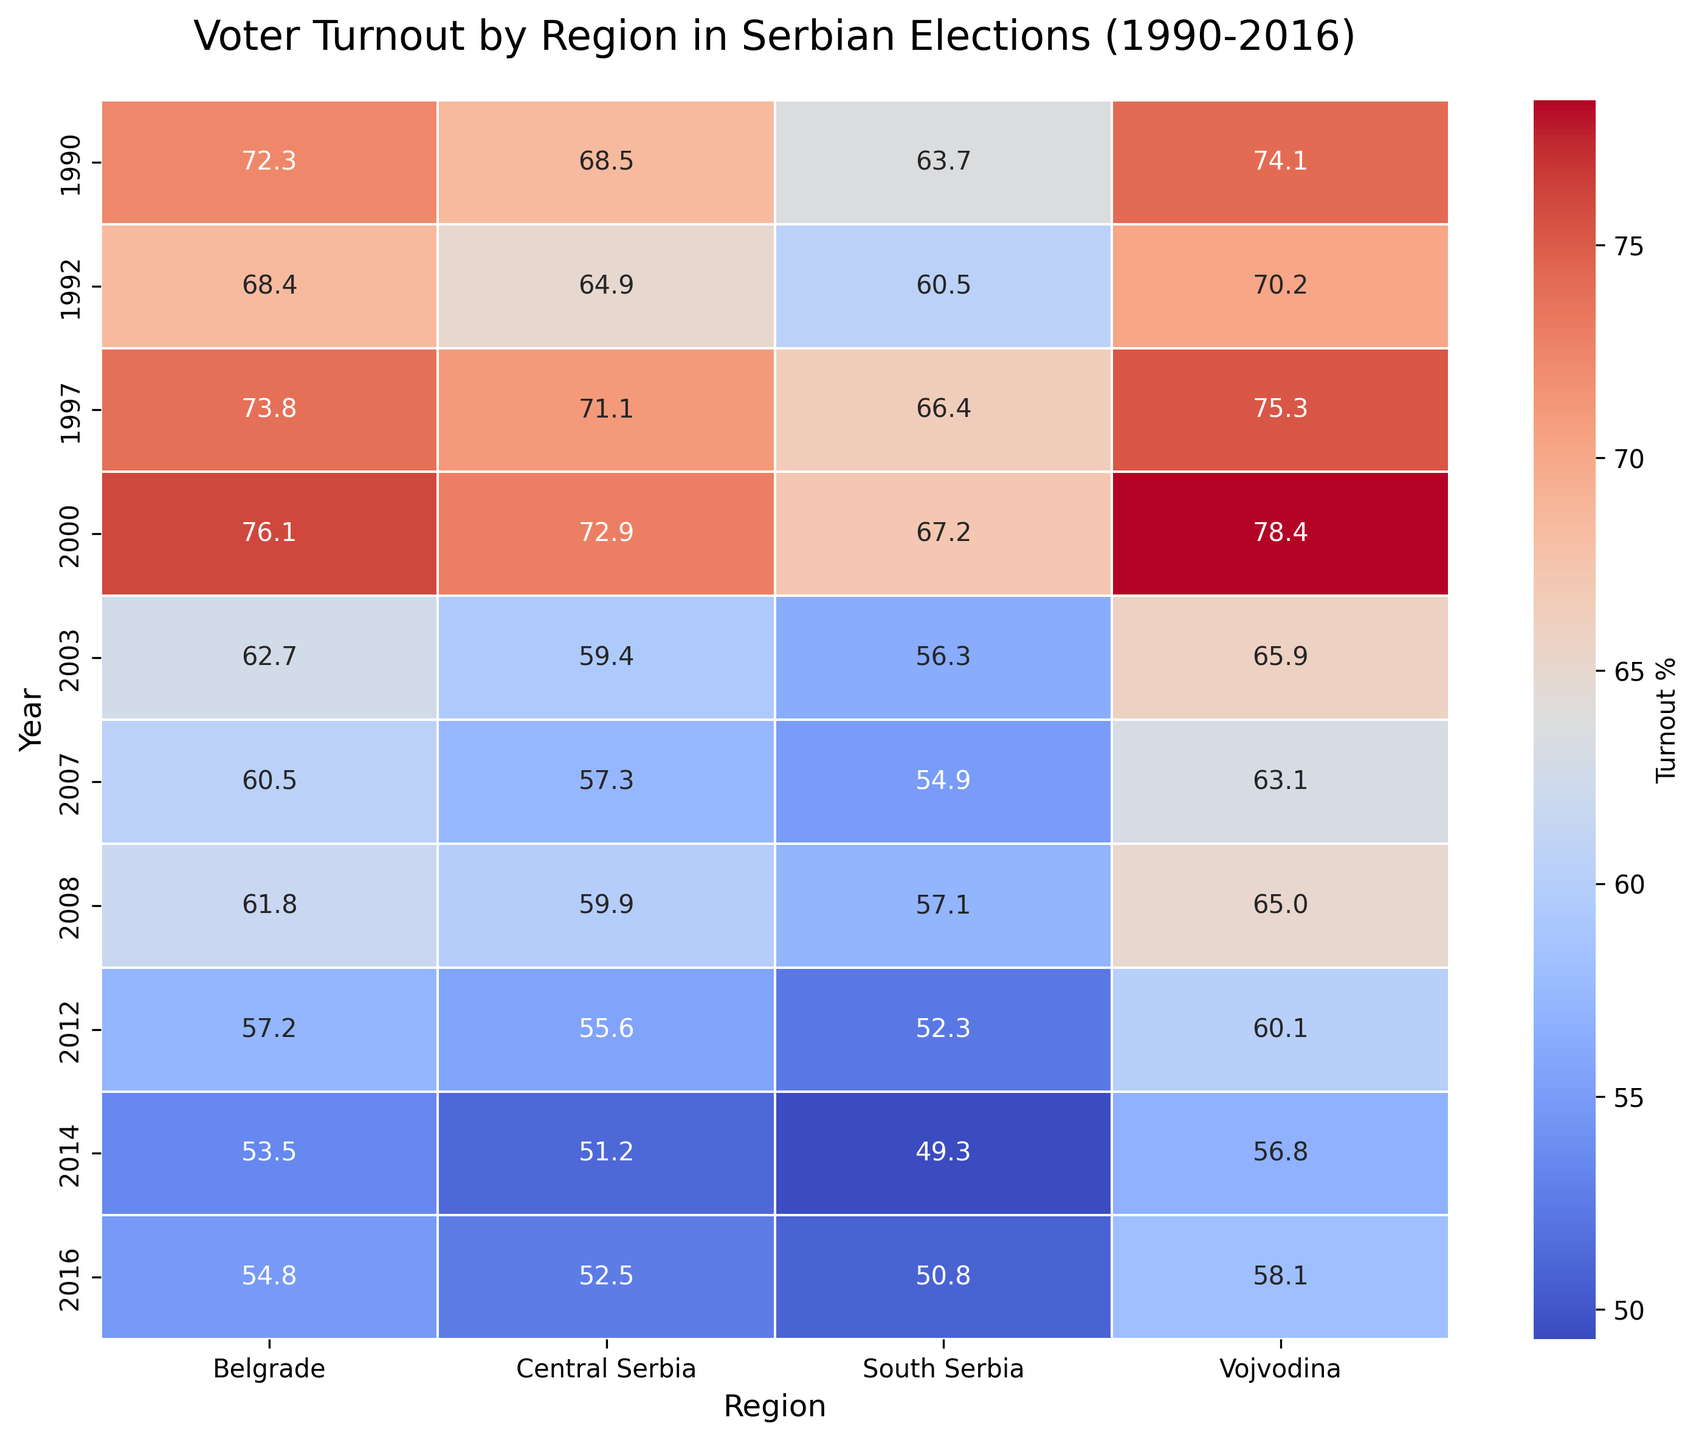What region had the highest voter turnout in 2000? By checking the heatmap's color intensities and the annotated numbers for each region under the 2000 row, the region with the highest percentage should be identified. For 2000, Vojvodina has the highest voter turnout percentage with 78.4%.
Answer: Vojvodina What was the difference in voter turnout between Belgrade and South Serbia in 2016? Locate the voter turnout percentages for both Belgrade and South Serbia in the 2016 row. Belgrade has 54.8% and South Serbia has 50.8%. Subtract the smaller number from the larger number: 54.8 - 50.8.
Answer: 4.0 Which year showed the lowest overall voter turnout in Belgrade? Review the column associated with Belgrade and identify the year with the smallest annotated number. The lowest turnout is in 2014 with 53.5%.
Answer: 2014 How did voter turnout in Central Serbia in 1997 compare to 2016? Check the heatmap for the voter turnout percentages for Central Serbia in 1997 and 2016. For 1997, it is 71.1%, and for 2016, it is 52.5%. Compare the two values; 71.1% is greater than 52.5%.
Answer: 1997 was higher Which region had the most significant decrease in voter turnout from 2000 to 2003? For each region, calculate the difference between the 2000 and 2003 values: Belgrade (76.1 - 62.7), Vojvodina (78.4 - 65.9), Central Serbia (72.9 - 59.4), South Serbia (67.2 - 56.3), and find the largest decrease. Belgrade had a decrease of 13.4%.
Answer: Belgrade What's the average voter turnout in Vojvodina over the entire period? Add up all the values in the Vojvodina column and divide by the number of years. The sum is (74.1 + 70.2 + 75.3 + 78.4 + 65.9 + 63.1 + 65.0 + 60.1 + 56.8 + 58.1) = 667.0. Divide by 10.
Answer: 66.7 Identify the year when South Serbia had the greatest improvement in voter turnout compared to the previous election. Calculate the year-over-year differences for South Serbia and identify the year with the highest positive change. The differences are -3.2 (1990-1992), 5.9 (1992-1997), 0.8 (1997-2000), -10.9 (2000-2003), 1.2 (2003-2007), 2.2 (2007-2008), -4.8 (2008-2012), -3.0 (2012-2014), 1.5 (2014-2016). The largest positive difference is in 1997 with an increase of 5.9%.
Answer: 1997 Did any region have a voter turnout percentage above 80%? Look through all the annotated percentages in the heatmap to see if any value exceeds 80%. None of the values are above 80%.
Answer: No Is the voter turnout trend in Belgrade generally increasing or decreasing from 1990 to 2016? Observe the color changes and the numerical annotation in the Belgrade column from top (1990) to bottom (2016). The trend shows a decrease from 72.3% in 1990 to 54.8% in 2016.
Answer: Decreasing 